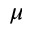Convert formula to latex. <formula><loc_0><loc_0><loc_500><loc_500>\mu</formula> 